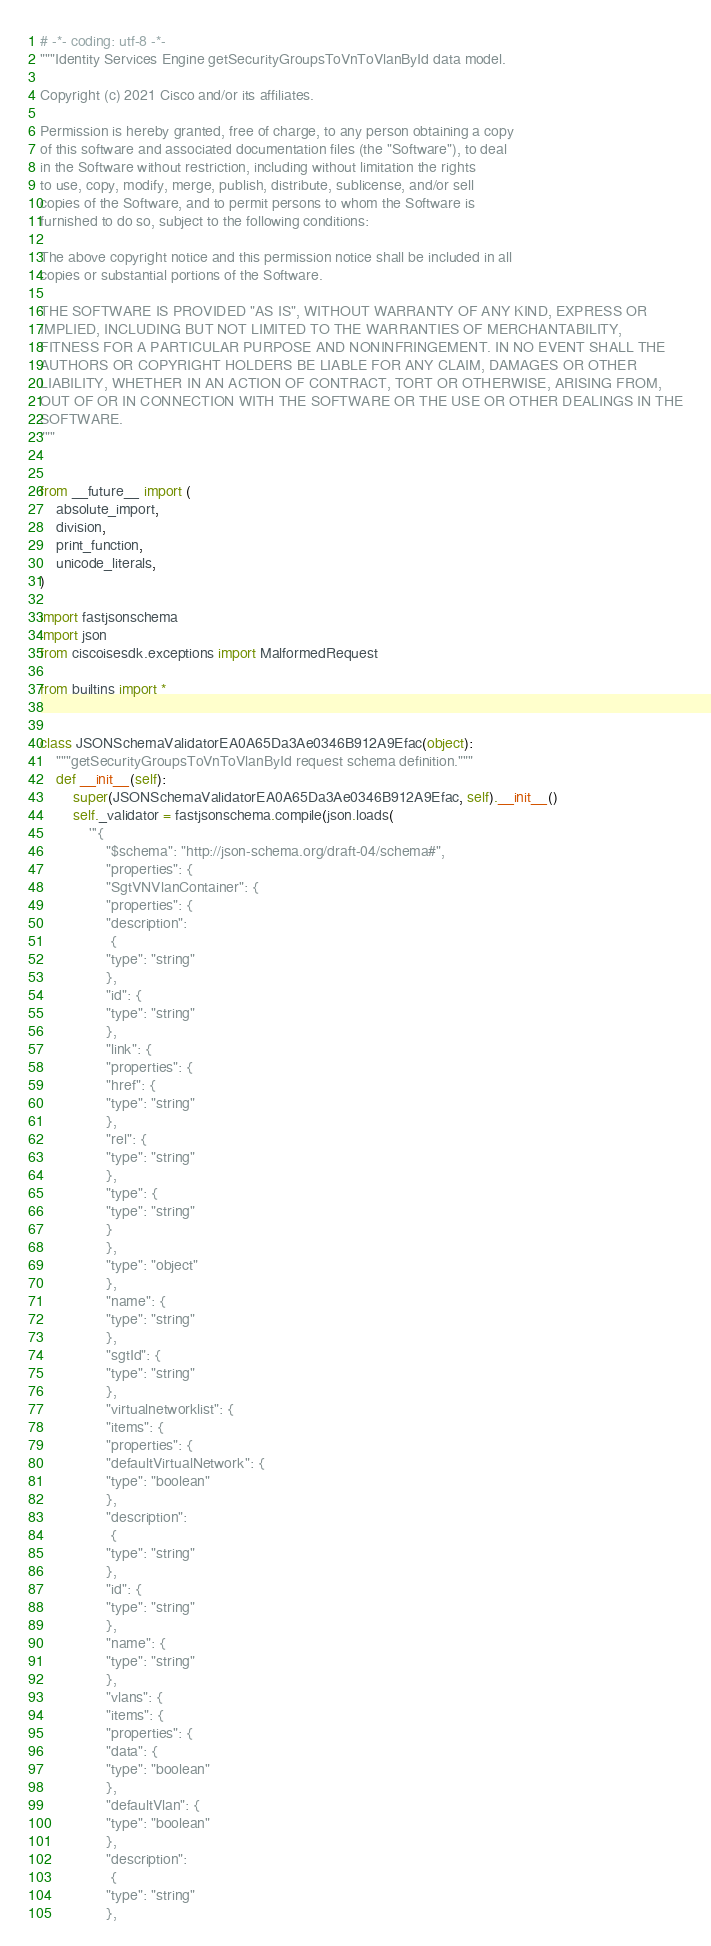<code> <loc_0><loc_0><loc_500><loc_500><_Python_># -*- coding: utf-8 -*-
"""Identity Services Engine getSecurityGroupsToVnToVlanById data model.

Copyright (c) 2021 Cisco and/or its affiliates.

Permission is hereby granted, free of charge, to any person obtaining a copy
of this software and associated documentation files (the "Software"), to deal
in the Software without restriction, including without limitation the rights
to use, copy, modify, merge, publish, distribute, sublicense, and/or sell
copies of the Software, and to permit persons to whom the Software is
furnished to do so, subject to the following conditions:

The above copyright notice and this permission notice shall be included in all
copies or substantial portions of the Software.

THE SOFTWARE IS PROVIDED "AS IS", WITHOUT WARRANTY OF ANY KIND, EXPRESS OR
IMPLIED, INCLUDING BUT NOT LIMITED TO THE WARRANTIES OF MERCHANTABILITY,
FITNESS FOR A PARTICULAR PURPOSE AND NONINFRINGEMENT. IN NO EVENT SHALL THE
AUTHORS OR COPYRIGHT HOLDERS BE LIABLE FOR ANY CLAIM, DAMAGES OR OTHER
LIABILITY, WHETHER IN AN ACTION OF CONTRACT, TORT OR OTHERWISE, ARISING FROM,
OUT OF OR IN CONNECTION WITH THE SOFTWARE OR THE USE OR OTHER DEALINGS IN THE
SOFTWARE.
"""


from __future__ import (
    absolute_import,
    division,
    print_function,
    unicode_literals,
)

import fastjsonschema
import json
from ciscoisesdk.exceptions import MalformedRequest

from builtins import *


class JSONSchemaValidatorEA0A65Da3Ae0346B912A9Efac(object):
    """getSecurityGroupsToVnToVlanById request schema definition."""
    def __init__(self):
        super(JSONSchemaValidatorEA0A65Da3Ae0346B912A9Efac, self).__init__()
        self._validator = fastjsonschema.compile(json.loads(
            '''{
                "$schema": "http://json-schema.org/draft-04/schema#",
                "properties": {
                "SgtVNVlanContainer": {
                "properties": {
                "description":
                 {
                "type": "string"
                },
                "id": {
                "type": "string"
                },
                "link": {
                "properties": {
                "href": {
                "type": "string"
                },
                "rel": {
                "type": "string"
                },
                "type": {
                "type": "string"
                }
                },
                "type": "object"
                },
                "name": {
                "type": "string"
                },
                "sgtId": {
                "type": "string"
                },
                "virtualnetworklist": {
                "items": {
                "properties": {
                "defaultVirtualNetwork": {
                "type": "boolean"
                },
                "description":
                 {
                "type": "string"
                },
                "id": {
                "type": "string"
                },
                "name": {
                "type": "string"
                },
                "vlans": {
                "items": {
                "properties": {
                "data": {
                "type": "boolean"
                },
                "defaultVlan": {
                "type": "boolean"
                },
                "description":
                 {
                "type": "string"
                },</code> 